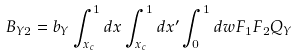<formula> <loc_0><loc_0><loc_500><loc_500>B _ { Y 2 } = b _ { Y } \int _ { x _ { c } } ^ { 1 } d x \int _ { x _ { c } } ^ { 1 } d x ^ { \prime } \int _ { 0 } ^ { 1 } d w F _ { 1 } F _ { 2 } Q _ { Y }</formula> 